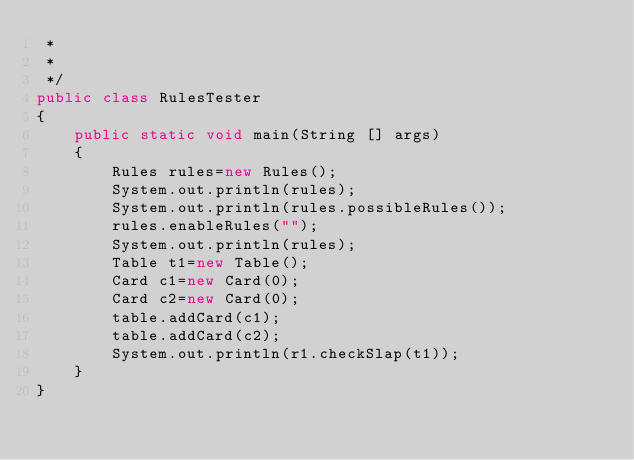<code> <loc_0><loc_0><loc_500><loc_500><_Java_> * 
 *
 */
public class RulesTester
{
    public static void main(String [] args)
    {
        Rules rules=new Rules();
        System.out.println(rules);
        System.out.println(rules.possibleRules());
        rules.enableRules("");
        System.out.println(rules);
        Table t1=new Table();
        Card c1=new Card(0);
        Card c2=new Card(0);
        table.addCard(c1);
        table.addCard(c2);        
        System.out.println(r1.checkSlap(t1));
    }
}
</code> 